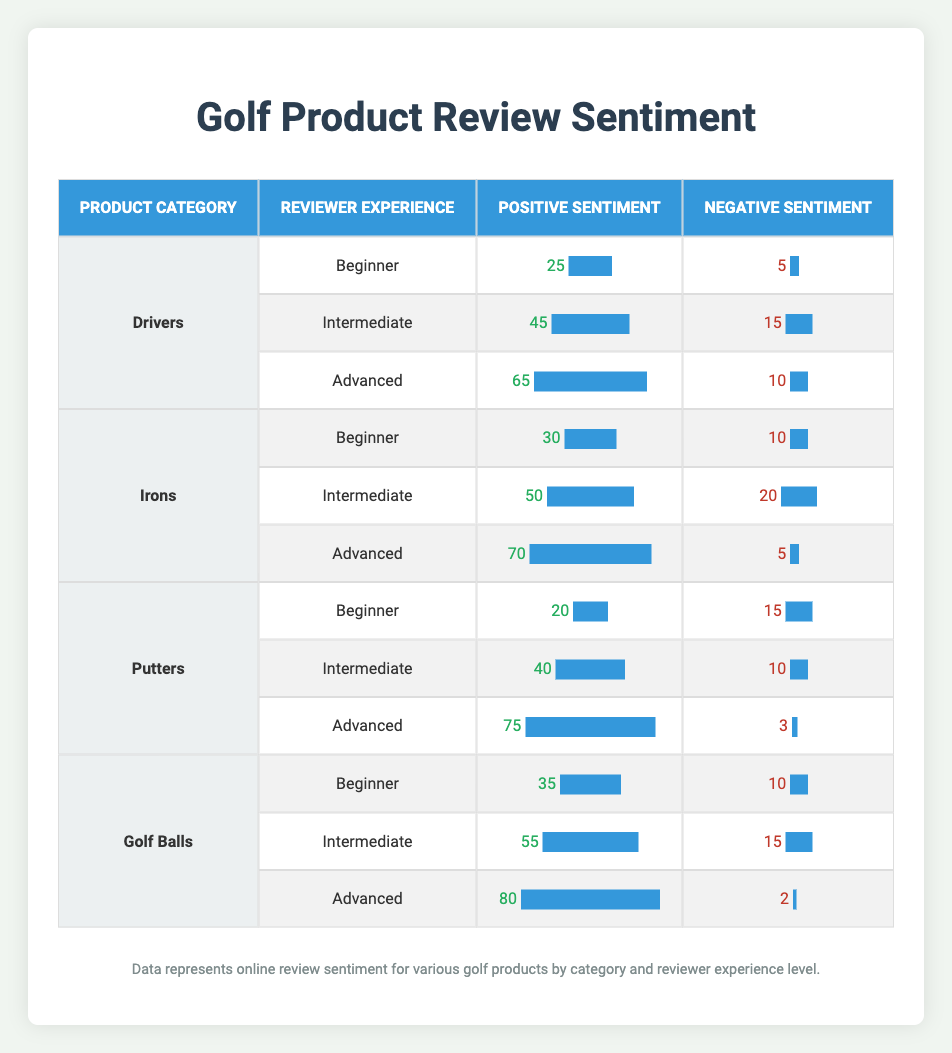What is the positive sentiment for Intermediate reviewers of Drivers? Looking at the table under the Drivers category for Intermediate reviewers, the positive sentiment is listed as 45.
Answer: 45 Which product category has the highest negative sentiment from Beginner reviewers? The table shows the negative sentiments for Beginners: Drivers (5), Irons (10), Putters (15), and Golf Balls (10). The highest among these is Putters with 15.
Answer: Putters What is the average positive sentiment for Advanced reviewers across all product categories? To find the average for Advanced reviewers, we sum the positive sentiments from each category: Drivers (65), Irons (70), Putters (75), and Golf Balls (80). The total is 65 + 70 + 75 + 80 = 290. There are 4 categories, so the average is 290/4 = 72.5.
Answer: 72.5 Is the positive sentiment for Irons by Advanced reviewers greater than that of Drivers by Intermediate reviewers? The positive sentiment for Irons by Advanced reviewers is 70, and for Drivers by Intermediate reviewers, it is 45. Since 70 is greater than 45, the answer is yes.
Answer: Yes What is the difference in negative sentiment between Intermediate and Advanced reviewers for Golf Balls? The negative sentiment for Intermediate reviewers of Golf Balls is 15, and for Advanced reviewers, it is 2. Calculating the difference: 15 - 2 = 13.
Answer: 13 